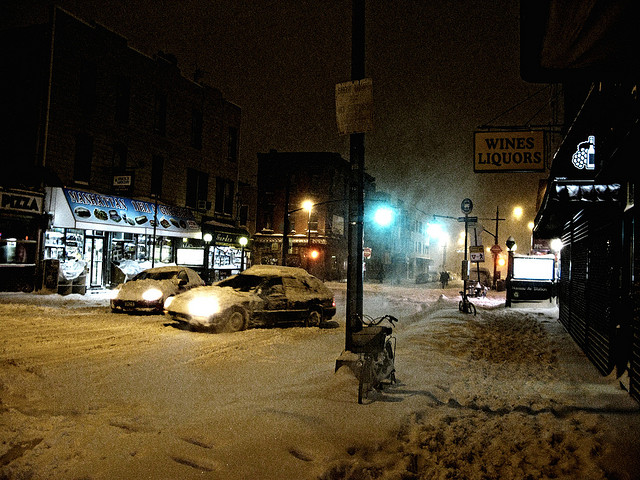Please extract the text content from this image. WINES LIQUORS PIZZA 